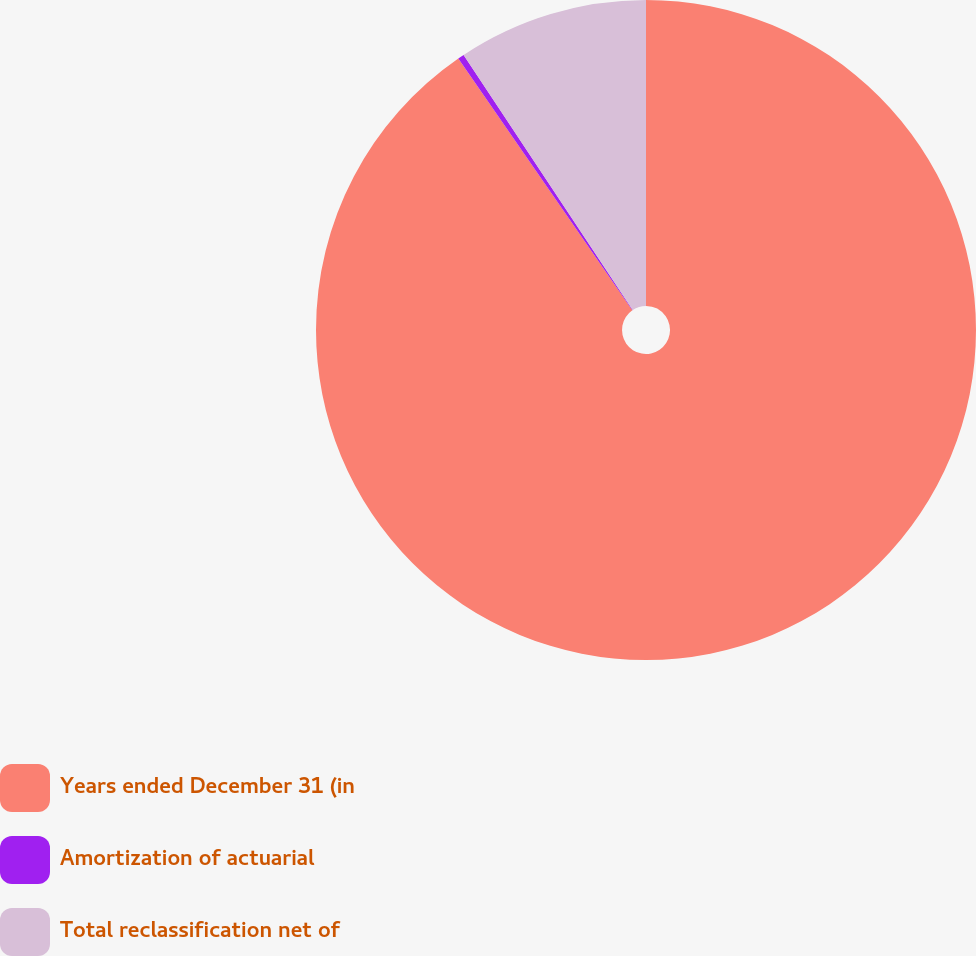Convert chart to OTSL. <chart><loc_0><loc_0><loc_500><loc_500><pie_chart><fcel>Years ended December 31 (in<fcel>Amortization of actuarial<fcel>Total reclassification net of<nl><fcel>90.37%<fcel>0.31%<fcel>9.32%<nl></chart> 